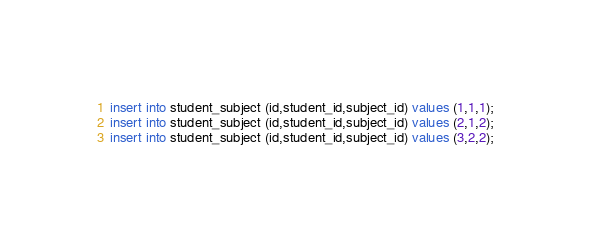Convert code to text. <code><loc_0><loc_0><loc_500><loc_500><_SQL_>insert into student_subject (id,student_id,subject_id) values (1,1,1);
insert into student_subject (id,student_id,subject_id) values (2,1,2);
insert into student_subject (id,student_id,subject_id) values (3,2,2);

</code> 